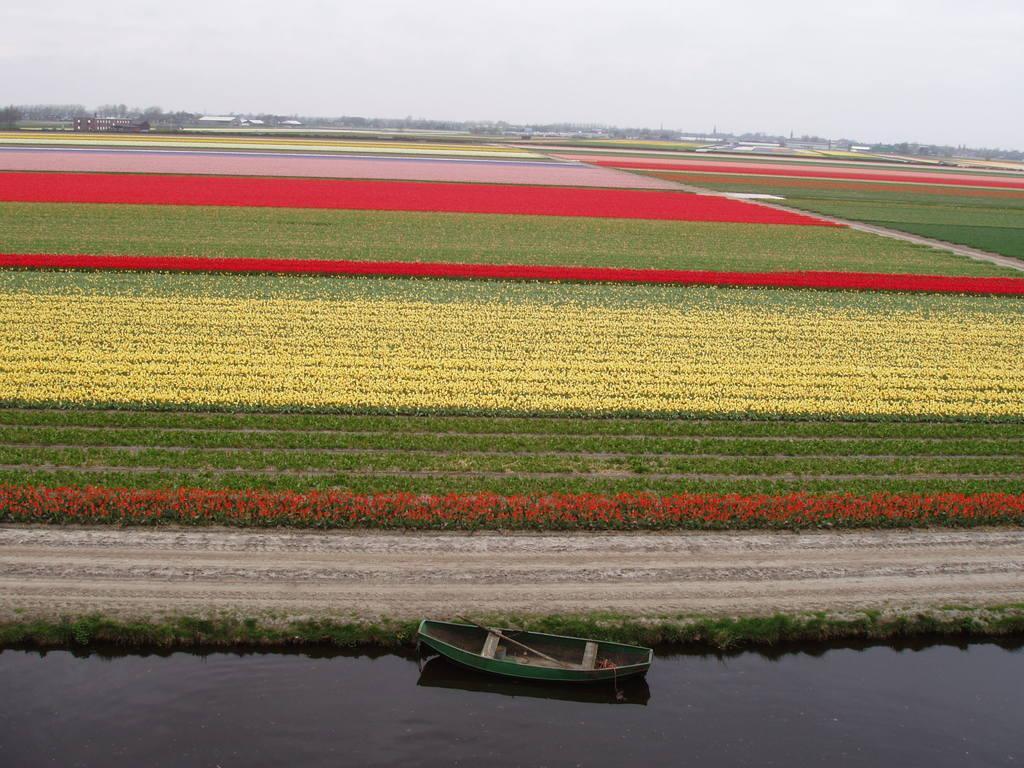In one or two sentences, can you explain what this image depicts? In this image I can see the boat on the water. To the side of the water I can see many flowers to the plants. The flowers are in red, yellow, pink. In the background I can see the white sky. 